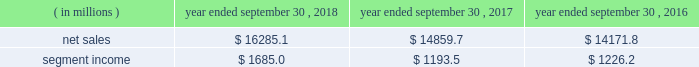Holders of grupo gondi manage the joint venture and we provide technical and commercial resources .
We believe the joint venture is helping us to grow our presence in the attractive mexican market .
We have included the financial results of the joint venture in our corrugated packaging segment since the date of formation .
We are accounting for the investment on the equity method .
On january 19 , 2016 , we completed the packaging acquisition .
The entities acquired provide value-added folding carton and litho-laminated display packaging solutions .
We believe the transaction has provided us with attractive and complementary customers , markets and facilities .
We have included the financial results of the acquired entities in our consumer packaging segment since the date of the acquisition .
On october 1 , 2015 , we completed the sp fiber acquisition .
The transaction included the acquisition of mills located in dublin , ga and newberg , or , which produce lightweight recycled containerboard and kraft and bag paper .
The newberg mill also produced newsprint .
As part of the transaction , we also acquired sp fiber's 48% ( 48 % ) interest in green power solutions of georgia , llc ( fffdgps fffd ) , which we consolidate .
Gps is a joint venture providing steam to the dublin mill and electricity to georgia power .
Subsequent to the transaction , we announced the permanent closure of the newberg mill due to the decline in market conditions of the newsprint business and our need to balance supply and demand in our containerboard system .
We have included the financial results of the acquired entities in our corrugated packaging segment since the date of the acquisition .
See fffdnote 2 .
Mergers , acquisitions and investment fffdtt of the notes to consolidated financial statements for additional information .
See also item 1a .
Fffdrisk factors fffd fffdwe may be unsuccessful in making and integrating mergers , acquisitions and investments and completing divestitures fffd .
Business .
In fiscal 2018 , we continued to pursue our strategy of offering differentiated paper and packaging solutions that help our customers win .
We successfully executed this strategy in fiscal 2018 in a rapidly changing cost and price environment .
Net sales of $ 16285.1 million for fiscal 2018 increased $ 1425.4 million , or 9.6% ( 9.6 % ) , compared to fiscal 2017 .
The increase was primarily a result of an increase in corrugated packaging segment sales , driven by higher selling price/mix and the contributions from acquisitions , and increased consumer packaging segment sales , primarily due to the contribution from acquisitions ( primarily the mps acquisition ) .
These increases were partially offset by the absence of net sales from hh&b in fiscal 2018 due to the sale of hh&b in april 2017 and lower land and development segment sales compared to the prior year period due to the timing of real estate sales as we monetize the portfolio and lower merchandising display sales in the consumer packaging segment .
Segment income increased $ 491.5 million in fiscal 2018 compared to fiscal 2017 , primarily due to increased corrugated packaging segment income .
With respect to segment income , we experienced higher levels of cost inflation during fiscal 2018 as compared to fiscal 2017 , which was partially offset by recycled fiber deflation .
The primary inflationary items were freight costs , chemical costs , virgin fiber costs and wage and other costs .
Productivity improvements in fiscal 2018 more than offset the net impact of cost inflation .
While it is difficult to predict specific inflationary items , we expect higher cost inflation to continue through fiscal 2019 .
Our corrugated packaging segment increased its net sales by $ 695.1 million in fiscal 2018 to $ 9103.4 million from $ 8408.3 million in fiscal 2017 .
The increase in net sales was primarily due to higher corrugated selling price/mix and higher corrugated volumes ( including acquisitions ) , which were partially offset by lower net sales from recycling operations due to lower recycled fiber costs , lower sales related to the deconsolidation of a foreign joint venture in fiscal 2017 and the impact of foreign currency .
North american box shipments increased 4.1% ( 4.1 % ) on a per day basis in fiscal 2018 compared to fiscal 2017 .
Segment income attributable to the corrugated packaging segment in fiscal 2018 increased $ 454.0 million to $ 1207.9 million compared to $ 753.9 million in fiscal 2017 .
The increase was primarily due to higher selling price/mix , lower recycled fiber costs and productivity improvements which were partially offset by higher levels of cost inflation and other items , including increased depreciation and amortization .
Our consumer packaging segment increased its net sales by $ 838.9 million in fiscal 2018 to $ 7291.4 million from $ 6452.5 million in fiscal 2017 .
The increase in net sales was primarily due to an increase in net sales from acquisitions ( primarily the mps acquisition ) and higher selling price/mix partially offset by the absence of net sales from hh&b in fiscal 2018 due to the hh&b sale in april 2017 and lower volumes .
Segment income attributable to .
What was the percentage increase in the segment income from 2016 to 2017? 
Computations: ((1685.0 - 1193.5) / 1193.5)
Answer: 0.41181. 